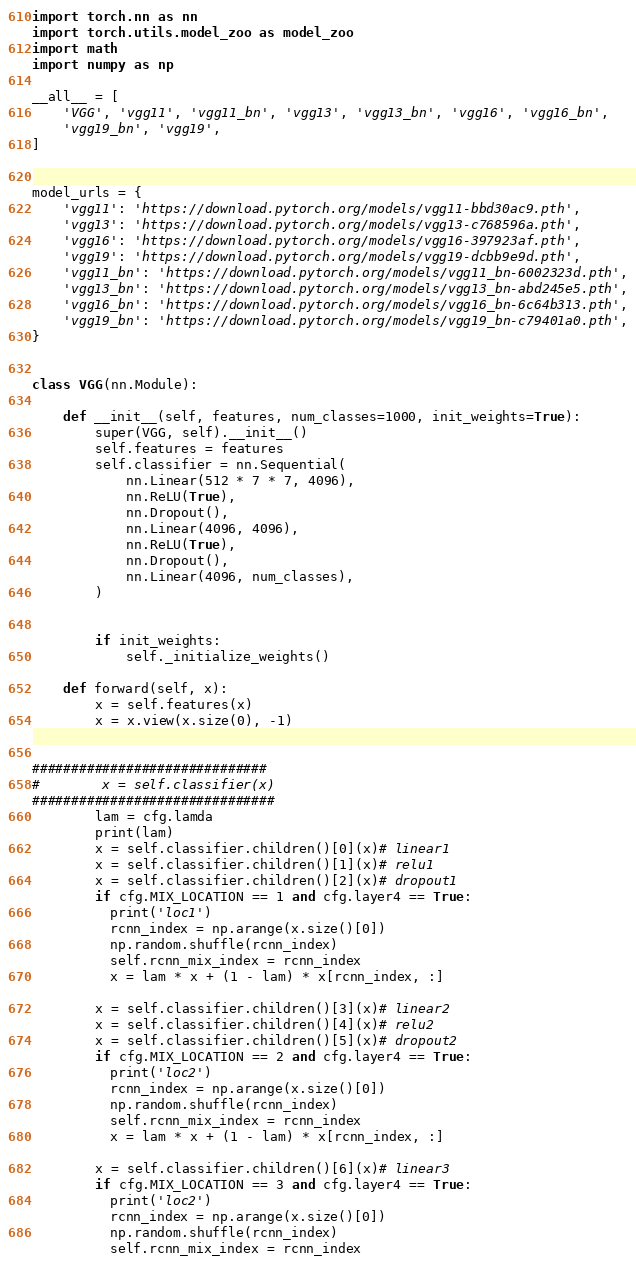Convert code to text. <code><loc_0><loc_0><loc_500><loc_500><_Python_>import torch.nn as nn
import torch.utils.model_zoo as model_zoo
import math
import numpy as np

__all__ = [
    'VGG', 'vgg11', 'vgg11_bn', 'vgg13', 'vgg13_bn', 'vgg16', 'vgg16_bn',
    'vgg19_bn', 'vgg19',
]


model_urls = {
    'vgg11': 'https://download.pytorch.org/models/vgg11-bbd30ac9.pth',
    'vgg13': 'https://download.pytorch.org/models/vgg13-c768596a.pth',
    'vgg16': 'https://download.pytorch.org/models/vgg16-397923af.pth',
    'vgg19': 'https://download.pytorch.org/models/vgg19-dcbb9e9d.pth',
    'vgg11_bn': 'https://download.pytorch.org/models/vgg11_bn-6002323d.pth',
    'vgg13_bn': 'https://download.pytorch.org/models/vgg13_bn-abd245e5.pth',
    'vgg16_bn': 'https://download.pytorch.org/models/vgg16_bn-6c64b313.pth',
    'vgg19_bn': 'https://download.pytorch.org/models/vgg19_bn-c79401a0.pth',
}


class VGG(nn.Module):

    def __init__(self, features, num_classes=1000, init_weights=True):
        super(VGG, self).__init__()
        self.features = features
        self.classifier = nn.Sequential(
            nn.Linear(512 * 7 * 7, 4096),
            nn.ReLU(True),
            nn.Dropout(),
            nn.Linear(4096, 4096),
            nn.ReLU(True),
            nn.Dropout(),
            nn.Linear(4096, num_classes),
        )


        if init_weights:
            self._initialize_weights()

    def forward(self, x):
        x = self.features(x)
        x = x.view(x.size(0), -1)


##############################
#        x = self.classifier(x)
###############################
        lam = cfg.lamda
        print(lam)
        x = self.classifier.children()[0](x)# linear1
        x = self.classifier.children()[1](x)# relu1
        x = self.classifier.children()[2](x)# dropout1
        if cfg.MIX_LOCATION == 1 and cfg.layer4 == True:
          print('loc1')
          rcnn_index = np.arange(x.size()[0])
          np.random.shuffle(rcnn_index)
          self.rcnn_mix_index = rcnn_index
          x = lam * x + (1 - lam) * x[rcnn_index, :]

        x = self.classifier.children()[3](x)# linear2
        x = self.classifier.children()[4](x)# relu2
        x = self.classifier.children()[5](x)# dropout2
        if cfg.MIX_LOCATION == 2 and cfg.layer4 == True:
          print('loc2')
          rcnn_index = np.arange(x.size()[0])
          np.random.shuffle(rcnn_index)
          self.rcnn_mix_index = rcnn_index
          x = lam * x + (1 - lam) * x[rcnn_index, :]

        x = self.classifier.children()[6](x)# linear3
        if cfg.MIX_LOCATION == 3 and cfg.layer4 == True:
          print('loc2')
          rcnn_index = np.arange(x.size()[0])
          np.random.shuffle(rcnn_index)
          self.rcnn_mix_index = rcnn_index</code> 